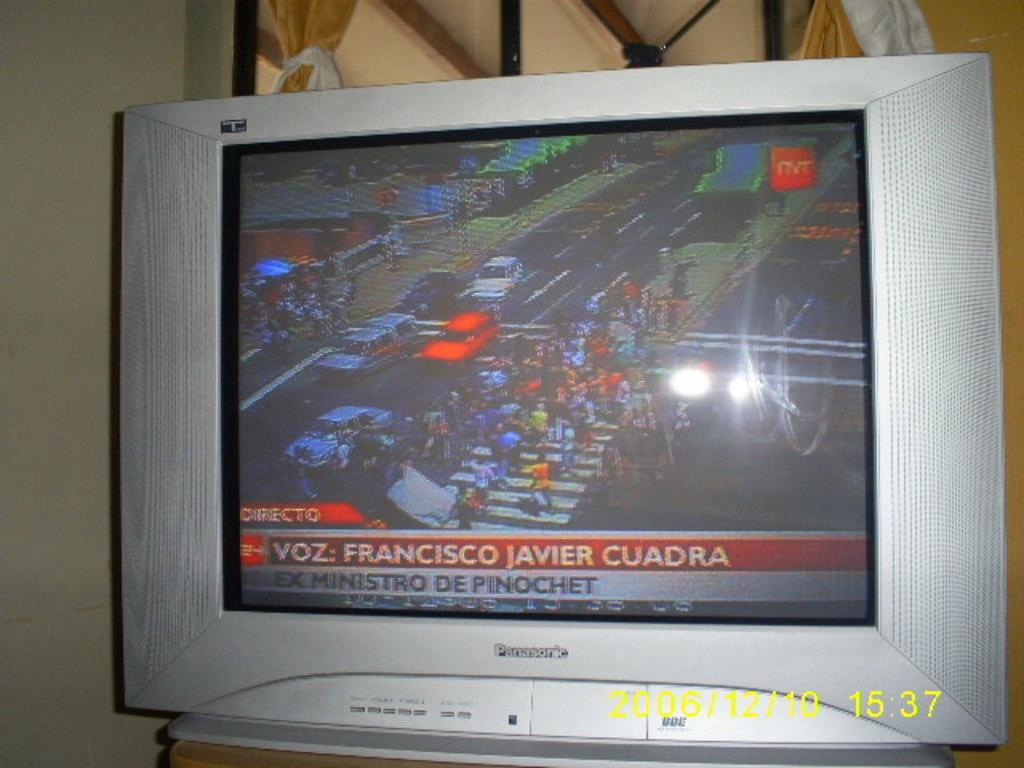<image>
Create a compact narrative representing the image presented. A Panasonic tv monitor shows people on a crosswalk. 